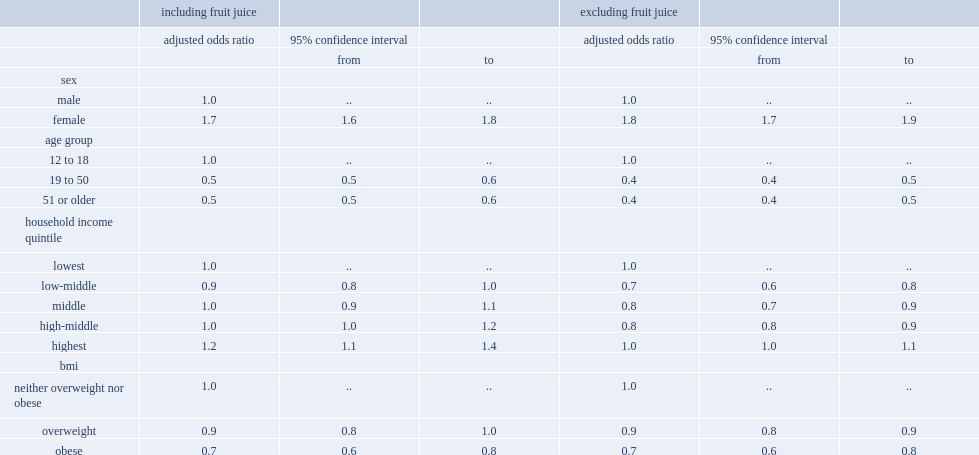Which group of people is more likely to report cosuming fruit and vegetables 5 or more times a day, male for female? Female. Which age group of people has a higher odd of reporting at least 5 times a day consuming fruit and vegetables? adults aged 19 to 50? 51 or older? or 12 o 18 year olds? 12 to 18. Which group of people has a higher odd of reporting 5 or more times a day when fruit juice was exclueded? Female. Which groups of people had a lower odds of reporting at least 5 times a day when fruit juice was excluded? individuals who were overweight or obese or those who were neither overweight nor obese? Overweight obese. 